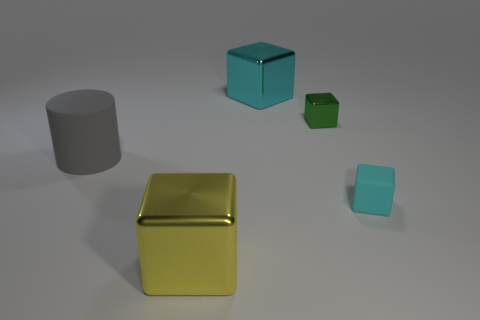Can you describe the lighting in the scene? The scene is softly lit from above, casting gentle shadows on the ground beneath each object, suggesting an indoor environment with diffuse overhead lighting. Is there a primary light source? While the primary light source isn't visible, its effects suggest it's located above the objects, slightly off-center, providing an even, diffused light across the scene. 